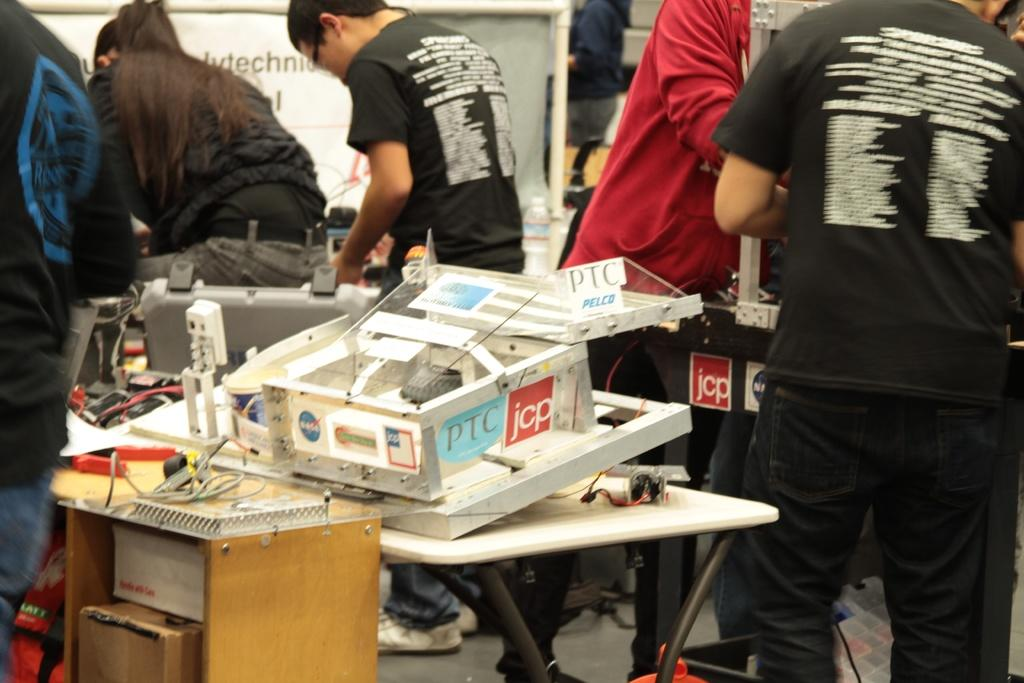What is on the table in the image? There is an equipment on a table in the image. Can you describe the people in the background of the image? Unfortunately, the provided facts do not give any information about the people in the background. What color is the playground equipment in the image? There is no playground equipment present in the image. What type of punishment is being administered to the person in the image? There is no person or punishment present in the image. 